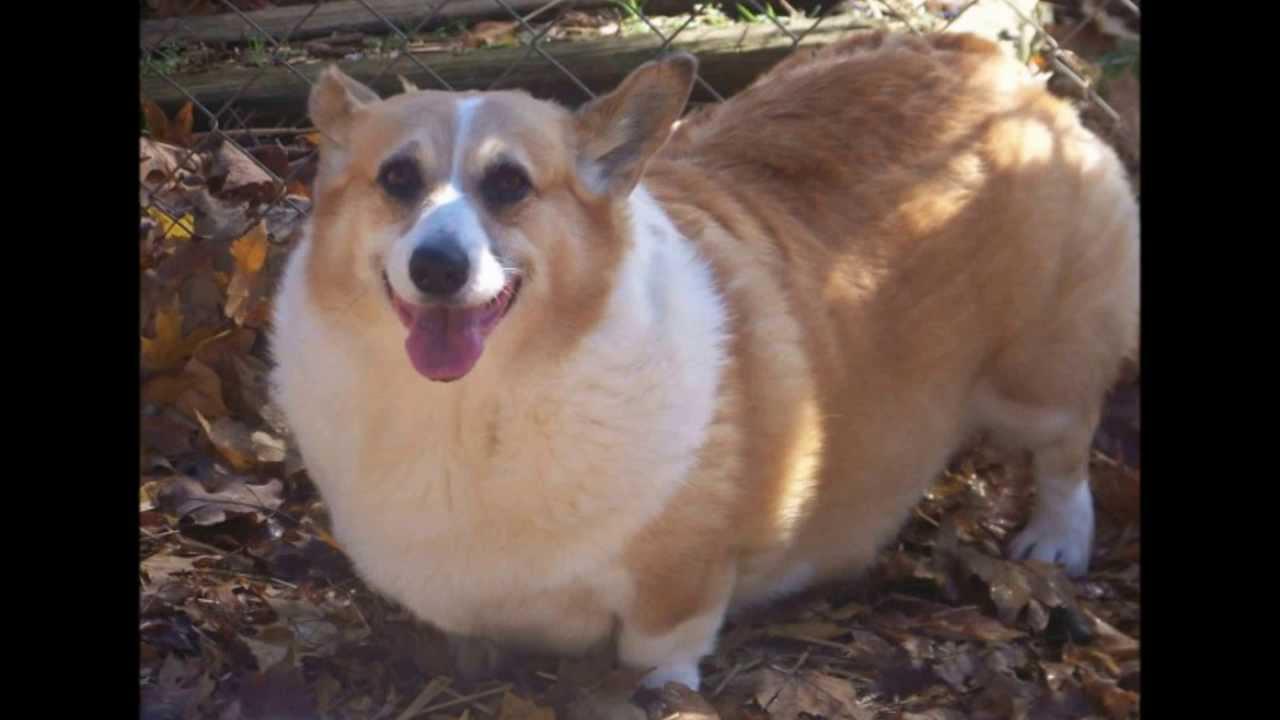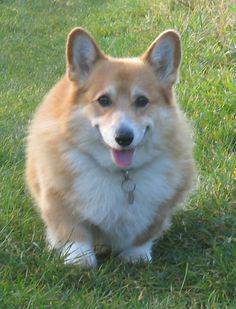The first image is the image on the left, the second image is the image on the right. Examine the images to the left and right. Is the description "One image contains at least twice as many corgi dogs as the other image." accurate? Answer yes or no. No. The first image is the image on the left, the second image is the image on the right. Evaluate the accuracy of this statement regarding the images: "There are at least three dogs.". Is it true? Answer yes or no. No. 